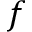<formula> <loc_0><loc_0><loc_500><loc_500>f</formula> 